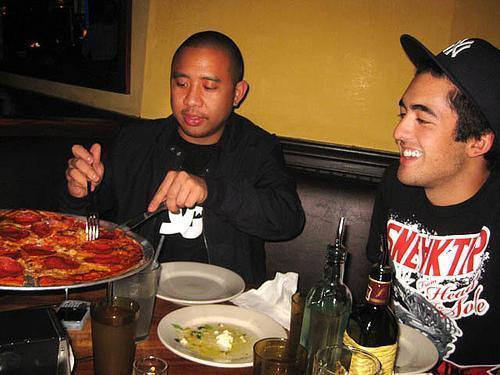How many bottles are there?
Give a very brief answer. 2. How many people are in the picture?
Give a very brief answer. 2. How many sinks are here?
Give a very brief answer. 0. 